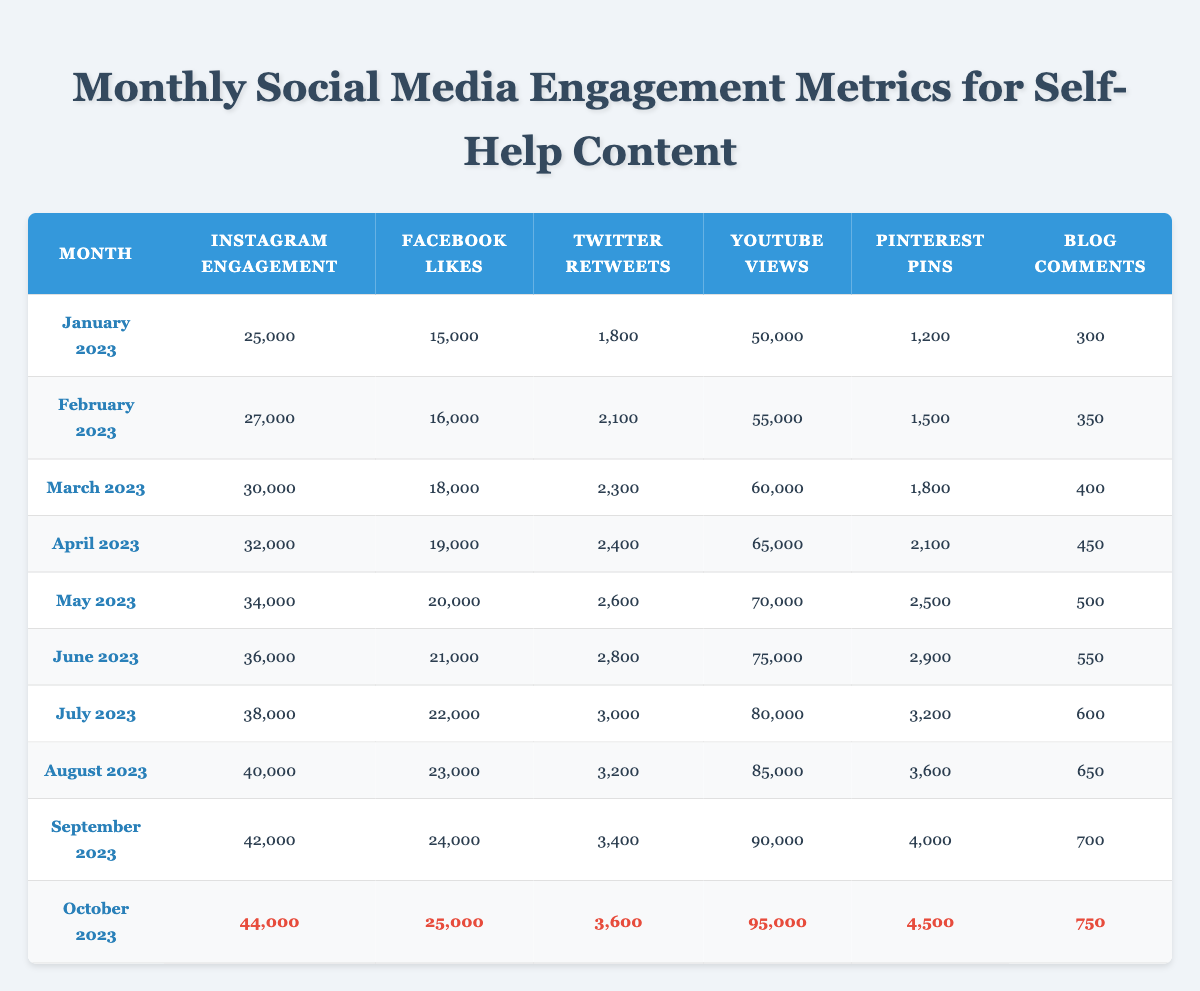What was the Instagram engagement in October 2023? The table shows that the Instagram engagement in October 2023 is listed as 44,000.
Answer: 44,000 Which month had the highest Facebook likes? By looking at the table, October 2023 has the highest number of Facebook likes at 25,000.
Answer: October 2023 How many YouTube views were there in September 2023? The table indicates that the YouTube views in September 2023 are 90,000.
Answer: 90,000 What is the total number of Blog comments from January to June 2023? Adding the Blog comments from January (300), February (350), March (400), April (450), May (500), and June (550) gives 300 + 350 + 400 + 450 + 500 + 550 = 3000.
Answer: 3000 Is the Twitter retweet count higher in July 2023 than in June 2023? The table shows July 2023 has 3,000 retweets, while June 2023 has 2,800 retweets. Therefore, July's count is higher.
Answer: Yes What was the increase in Instagram engagement from January to August 2023? Instagram engagement increased from 25,000 in January to 40,000 in August. The difference is 40,000 - 25,000 = 15,000.
Answer: 15,000 What was the average number of Pinterest pins from January to October 2023? The total Pinterest pins from January (1,200), February (1,500), March (1,800), April (2,100), May (2,500), June (2,900), July (3,200), August (3,600), September (4,000), and October (4,500) is 1,200 + 1,500 + 1,800 + 2,100 + 2,500 + 2,900 + 3,200 + 3,600 + 4,000 + 4,500 =  30,300. To find the average, we divide by 10 months: 30,300 / 10 = 3,030.
Answer: 3,030 What percentage increase in YouTube views occurred from June to October 2023? June 2023 had 75,000 views and October 2023 had 95,000 views. The increase is 95,000 - 75,000 = 20,000. The percentage increase is (20,000 / 75,000) * 100 = 26.67%.
Answer: 26.67% Which social media platform had the least engagement in January 2023? In January 2023, Blog comments with 300 were the least compared to other platforms listed.
Answer: Blog comments Did engagement metrics for self-help content generally increase from January to October 2023? Reviewing the table data, all metrics show an upward trend across the months from January to October 2023.
Answer: Yes 